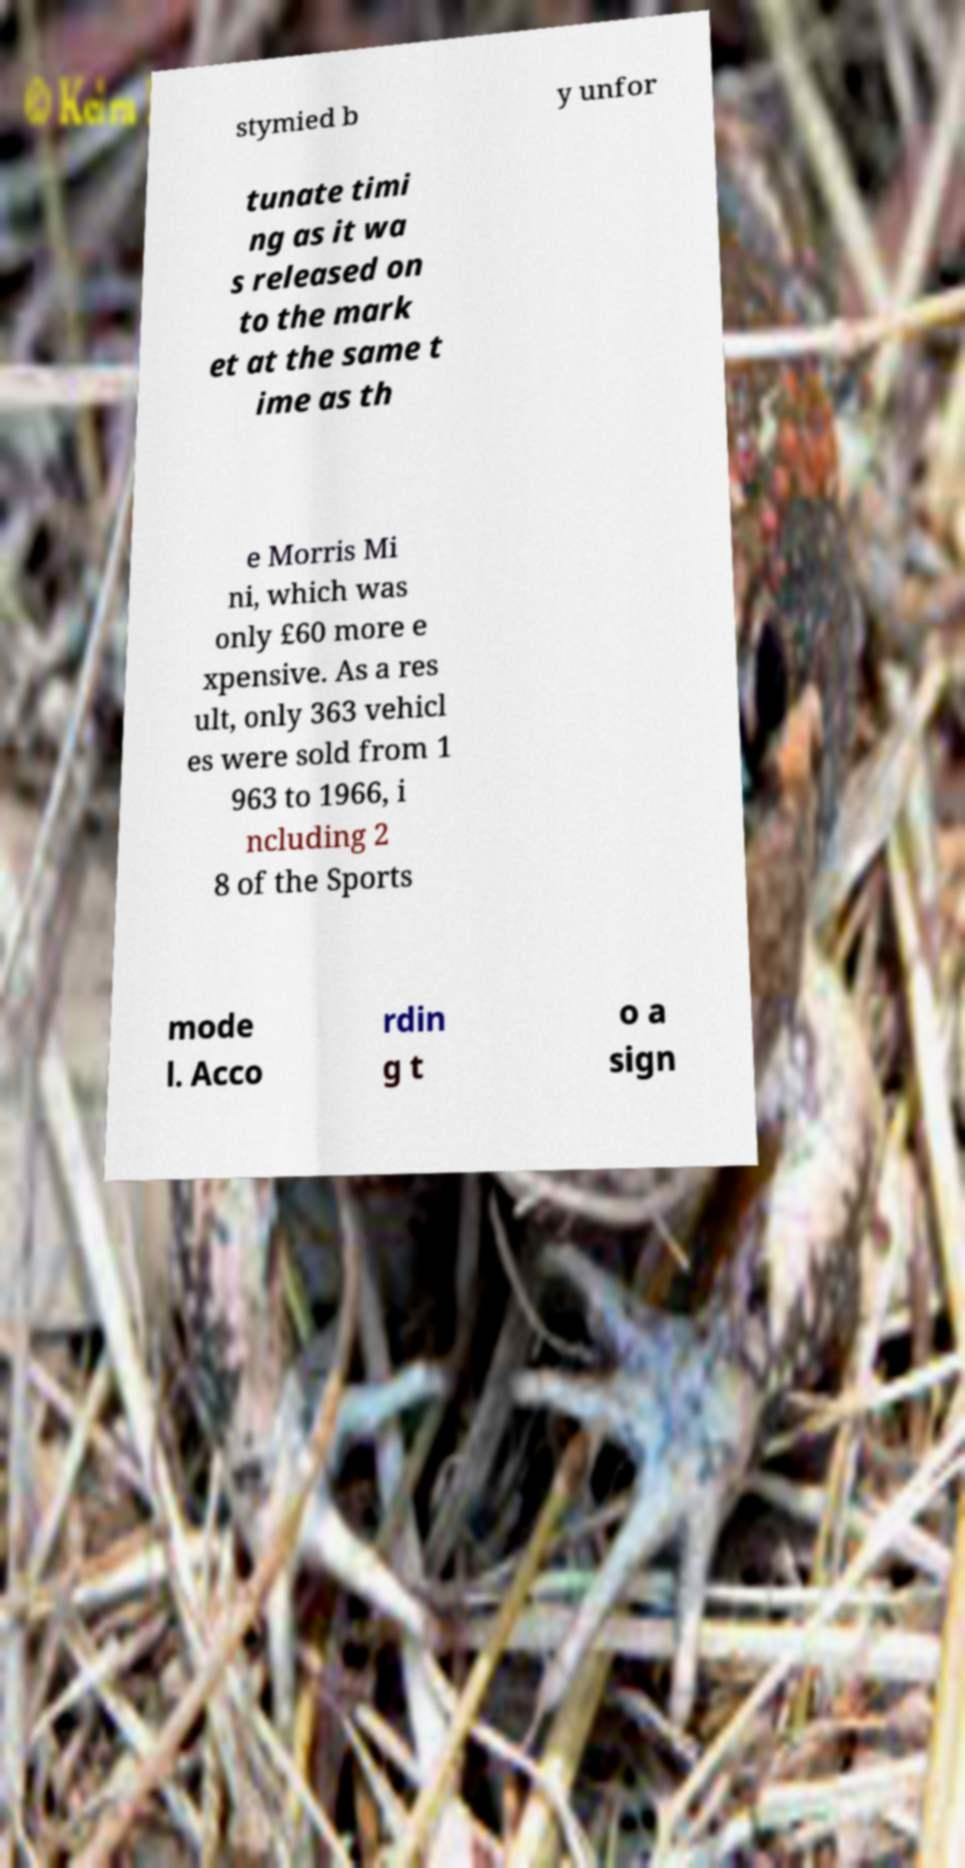Could you extract and type out the text from this image? stymied b y unfor tunate timi ng as it wa s released on to the mark et at the same t ime as th e Morris Mi ni, which was only £60 more e xpensive. As a res ult, only 363 vehicl es were sold from 1 963 to 1966, i ncluding 2 8 of the Sports mode l. Acco rdin g t o a sign 